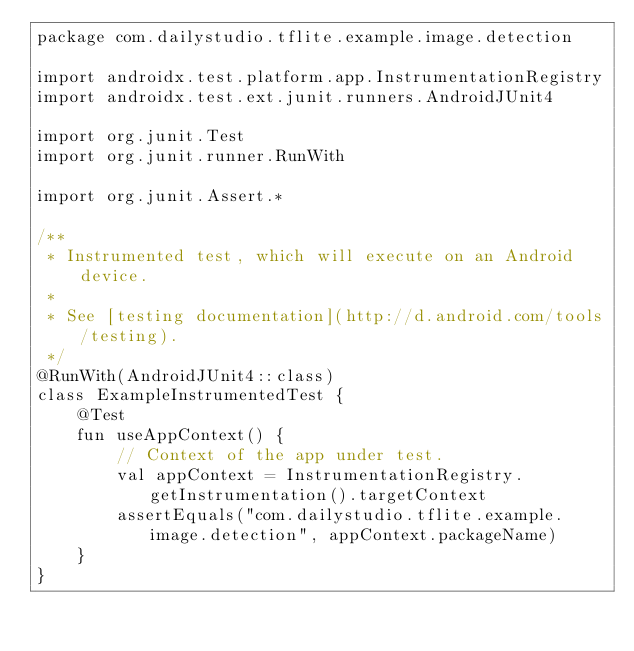<code> <loc_0><loc_0><loc_500><loc_500><_Kotlin_>package com.dailystudio.tflite.example.image.detection

import androidx.test.platform.app.InstrumentationRegistry
import androidx.test.ext.junit.runners.AndroidJUnit4

import org.junit.Test
import org.junit.runner.RunWith

import org.junit.Assert.*

/**
 * Instrumented test, which will execute on an Android device.
 *
 * See [testing documentation](http://d.android.com/tools/testing).
 */
@RunWith(AndroidJUnit4::class)
class ExampleInstrumentedTest {
    @Test
    fun useAppContext() {
        // Context of the app under test.
        val appContext = InstrumentationRegistry.getInstrumentation().targetContext
        assertEquals("com.dailystudio.tflite.example.image.detection", appContext.packageName)
    }
}
</code> 